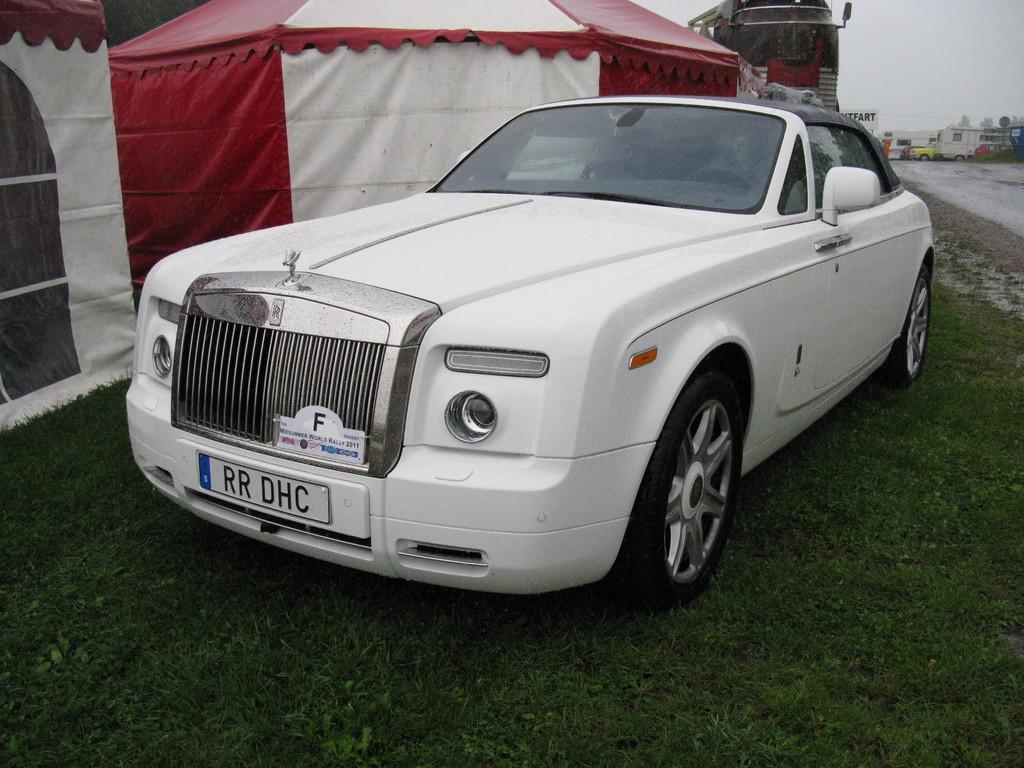How would you summarize this image in a sentence or two? In the picture I can see a white color car is parked on the grass. In the background, I can see the tents, I can see houses, a few more vehicles, boards and the cloudy sky in the background. 